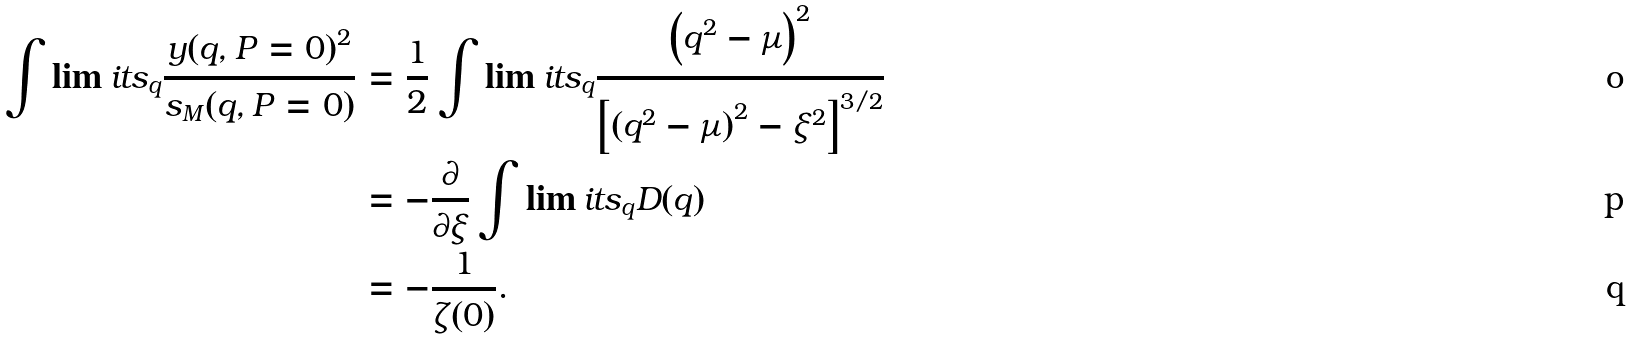<formula> <loc_0><loc_0><loc_500><loc_500>\int \lim i t s _ { q } \frac { y ( q , P = 0 ) ^ { 2 } } { s _ { M } ( q , P = 0 ) } & = \frac { 1 } { 2 } \int \lim i t s _ { q } \frac { \left ( q ^ { 2 } - \mu \right ) ^ { 2 } } { \left [ \left ( q ^ { 2 } - \mu \right ) ^ { 2 } - \xi ^ { 2 } \right ] ^ { 3 / 2 } } \\ & = - \frac { \partial } { \partial \xi } \int \lim i t s _ { q } D ( q ) \\ & = - \frac { 1 } { \zeta ( 0 ) } .</formula> 